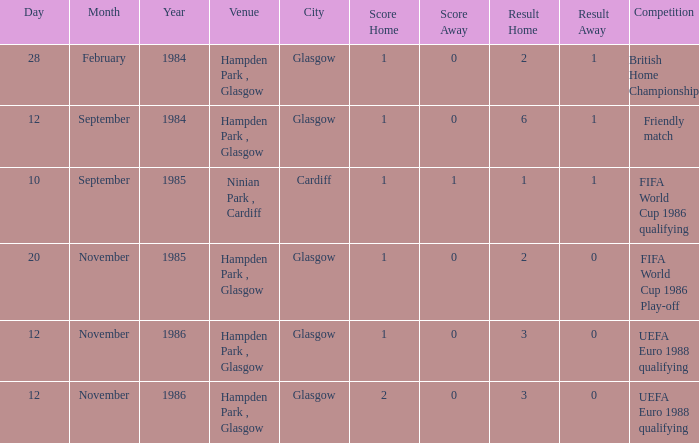What is the Score of the Fifa World Cup 1986 Qualifying Competition? 1–1. 